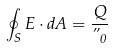Convert formula to latex. <formula><loc_0><loc_0><loc_500><loc_500>\oint _ { S } E \cdot d A = { \frac { Q } { \varepsilon _ { 0 } } }</formula> 